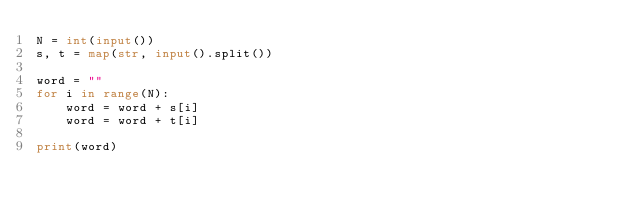Convert code to text. <code><loc_0><loc_0><loc_500><loc_500><_Python_>N = int(input())
s, t = map(str, input().split())

word = ""
for i in range(N):
    word = word + s[i]
    word = word + t[i]

print(word)</code> 